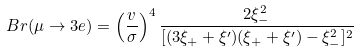Convert formula to latex. <formula><loc_0><loc_0><loc_500><loc_500>B r ( \mu \rightarrow 3 e ) = \left ( \frac { v } { \sigma } \right ) ^ { 4 } \frac { 2 \xi _ { - } ^ { 2 } } { [ ( 3 \xi _ { + } + \xi ^ { \prime } ) ( \xi _ { + } + \xi ^ { \prime } ) - \xi _ { - } ^ { 2 } ] ^ { 2 } }</formula> 